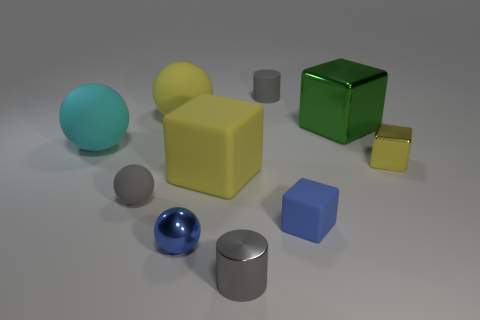Subtract all large cyan matte balls. How many balls are left? 3 Subtract all cyan spheres. How many yellow cubes are left? 2 Subtract all blue cubes. How many cubes are left? 3 Subtract 4 spheres. How many spheres are left? 0 Subtract all cubes. How many objects are left? 6 Add 5 yellow cubes. How many yellow cubes are left? 7 Add 2 big purple matte cylinders. How many big purple matte cylinders exist? 2 Subtract 0 blue cylinders. How many objects are left? 10 Subtract all cyan spheres. Subtract all green cubes. How many spheres are left? 3 Subtract all big cubes. Subtract all tiny gray rubber cylinders. How many objects are left? 7 